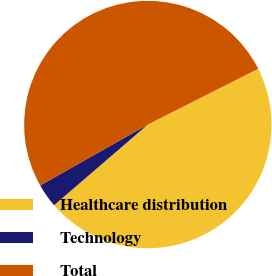Convert chart. <chart><loc_0><loc_0><loc_500><loc_500><pie_chart><fcel>Healthcare distribution<fcel>Technology<fcel>Total<nl><fcel>46.14%<fcel>3.11%<fcel>50.75%<nl></chart> 